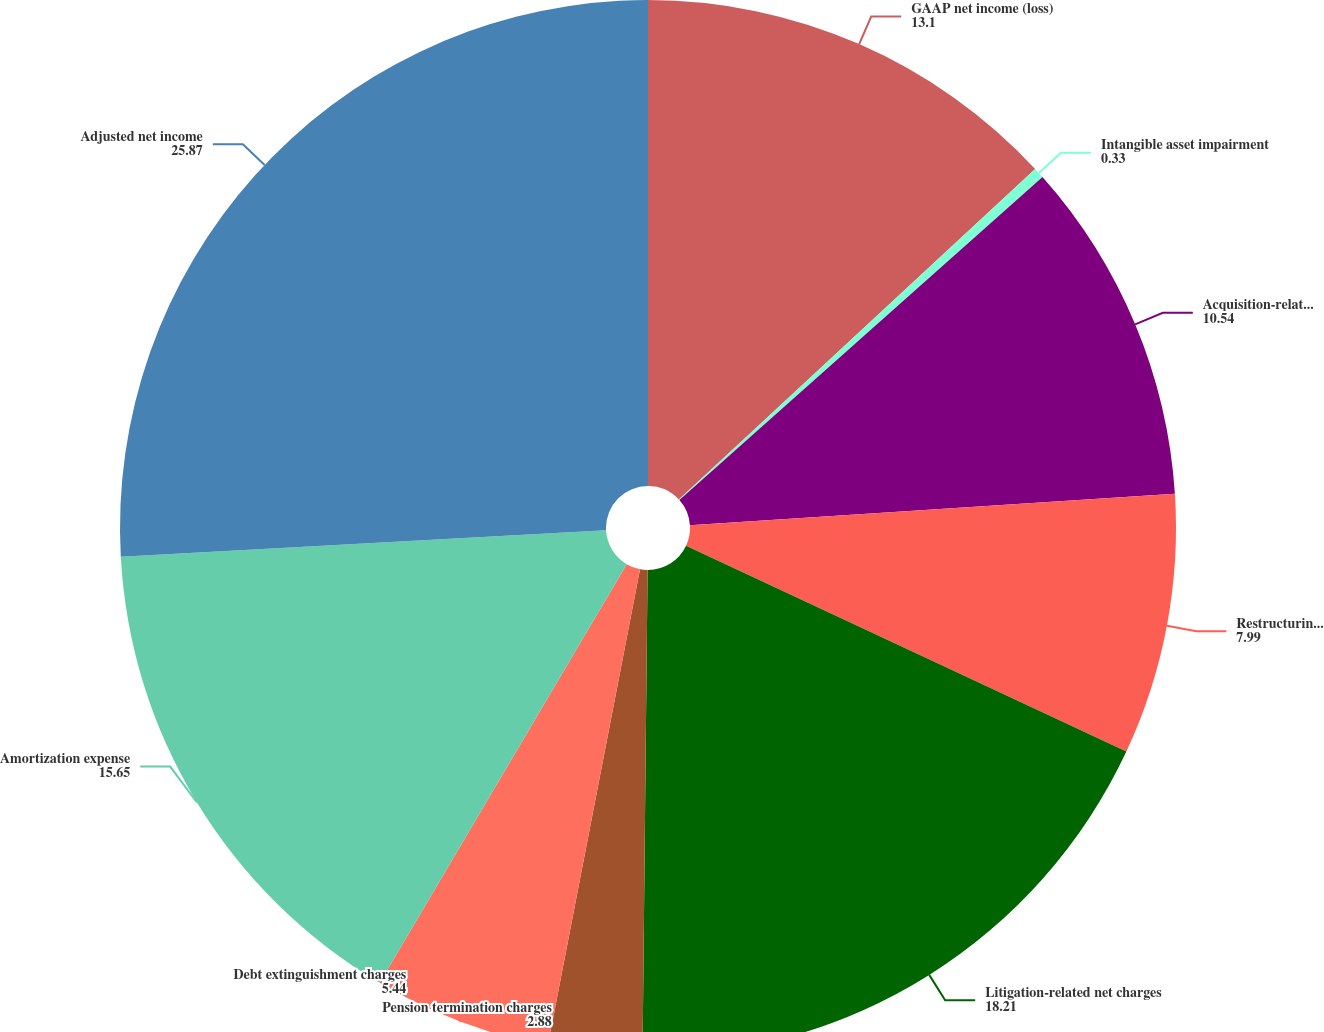Convert chart to OTSL. <chart><loc_0><loc_0><loc_500><loc_500><pie_chart><fcel>GAAP net income (loss)<fcel>Intangible asset impairment<fcel>Acquisition-related net<fcel>Restructuring and<fcel>Litigation-related net charges<fcel>Pension termination charges<fcel>Debt extinguishment charges<fcel>Amortization expense<fcel>Adjusted net income<nl><fcel>13.1%<fcel>0.33%<fcel>10.54%<fcel>7.99%<fcel>18.21%<fcel>2.88%<fcel>5.44%<fcel>15.65%<fcel>25.87%<nl></chart> 